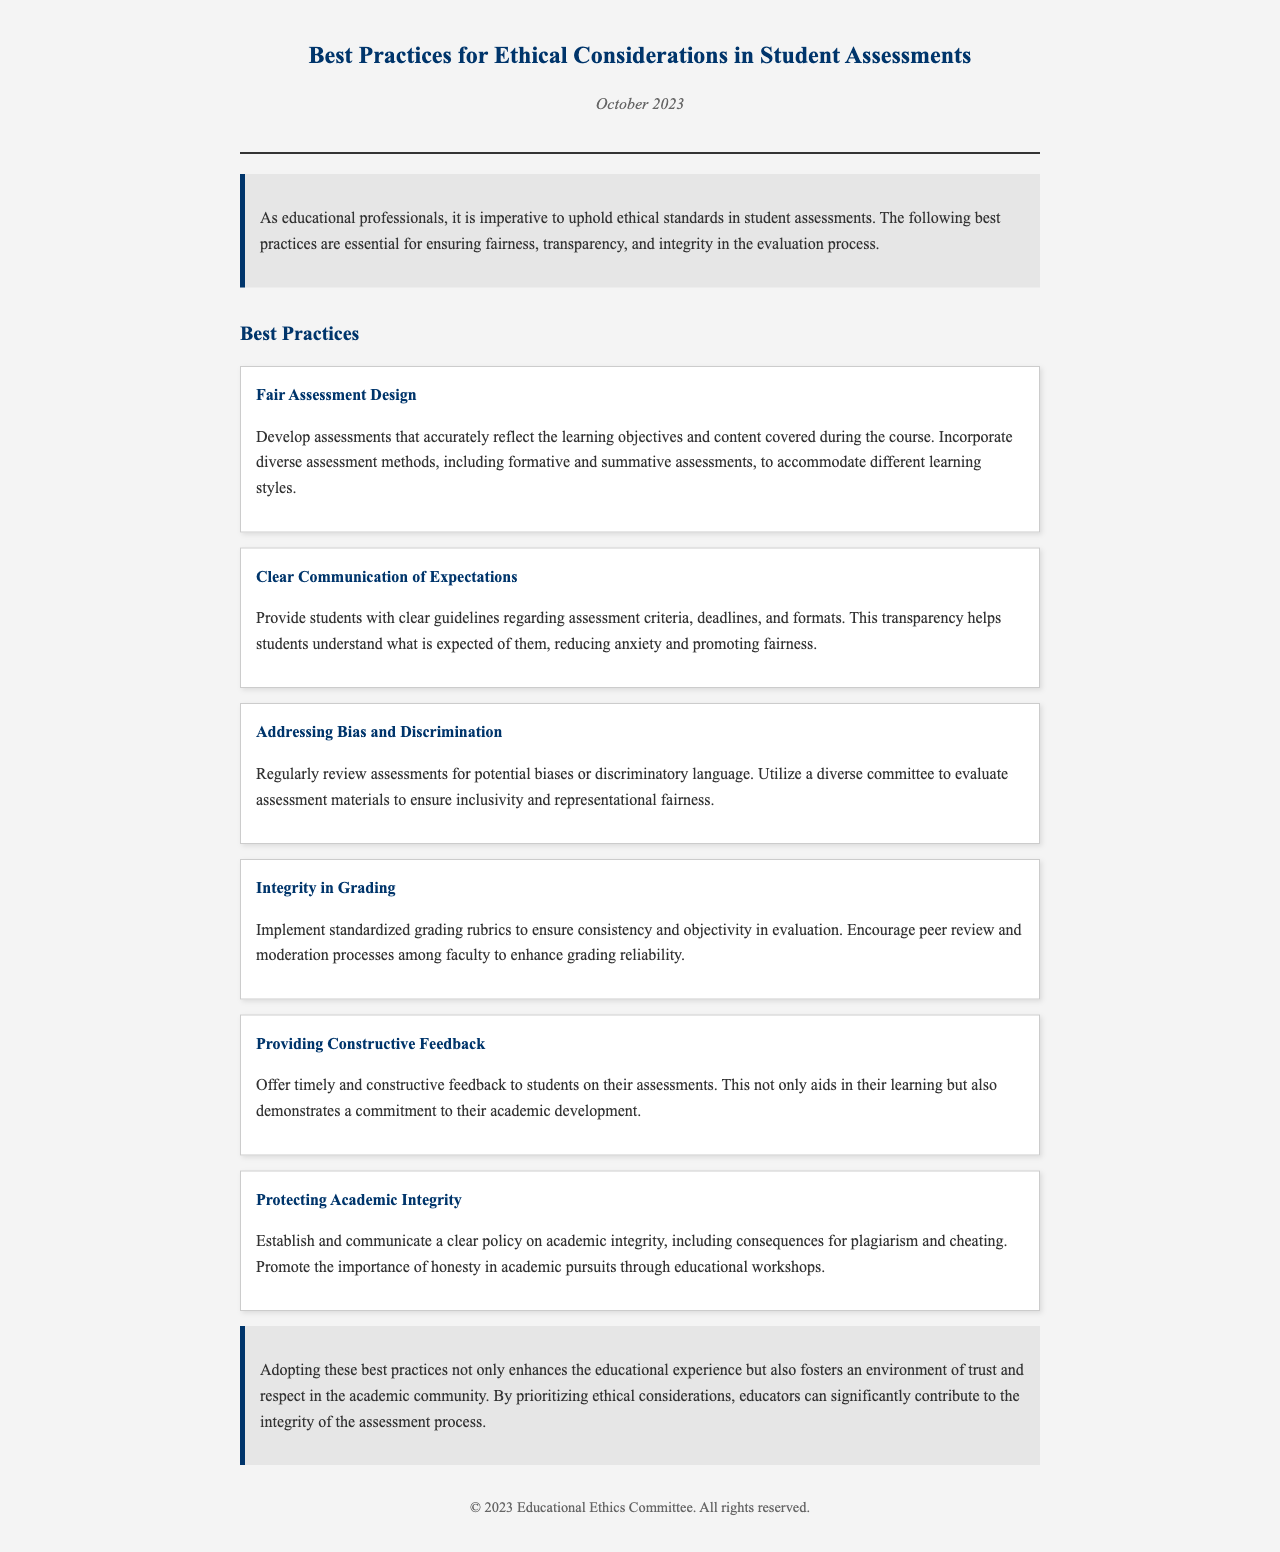What is the title of the document? The title is specified in the header section of the document.
Answer: Best Practices for Ethical Considerations in Student Assessments When was the document published? The publication date is mentioned below the title in the header.
Answer: October 2023 What is the first best practice mentioned? The first best practice is the initial one listed under the Best Practices section.
Answer: Fair Assessment Design What is emphasized in the practice regarding addressing bias? The document advises on a specific action regarding assessment review.
Answer: Regularly review assessments for potential biases or discriminatory language What is one of the goals of providing constructive feedback? The document highlights the purpose of feedback in the context of student learning.
Answer: Aids in their learning How should grading be conducted according to the document? The document suggests a particular method to enhance grading reliability.
Answer: Implement standardized grading rubrics What is the main theme of the conclusion? The conclusion summarizes the importance of implementing certain practices in education.
Answer: Enhances the educational experience What type of document is this? The structure and content indicate a specific format.
Answer: Newsletter 